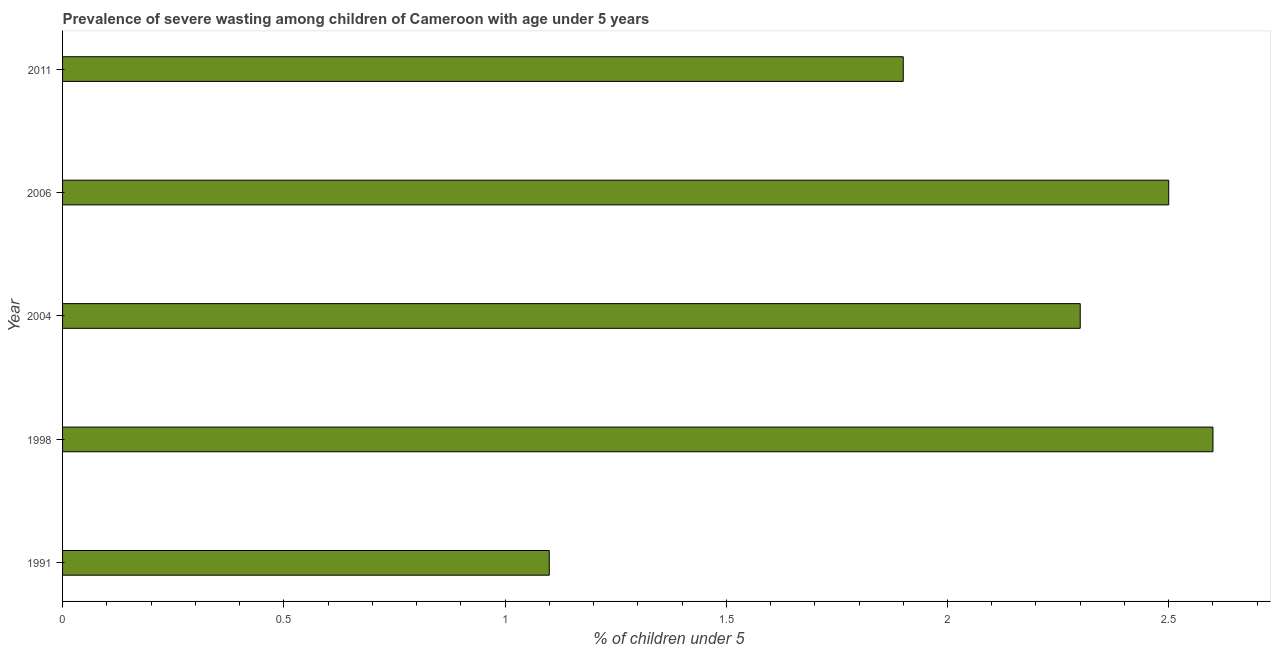Does the graph contain any zero values?
Provide a succinct answer. No. Does the graph contain grids?
Keep it short and to the point. No. What is the title of the graph?
Offer a terse response. Prevalence of severe wasting among children of Cameroon with age under 5 years. What is the label or title of the X-axis?
Offer a very short reply.  % of children under 5. What is the prevalence of severe wasting in 2011?
Give a very brief answer. 1.9. Across all years, what is the maximum prevalence of severe wasting?
Ensure brevity in your answer.  2.6. Across all years, what is the minimum prevalence of severe wasting?
Keep it short and to the point. 1.1. What is the sum of the prevalence of severe wasting?
Offer a very short reply. 10.4. What is the average prevalence of severe wasting per year?
Provide a succinct answer. 2.08. What is the median prevalence of severe wasting?
Offer a very short reply. 2.3. In how many years, is the prevalence of severe wasting greater than 0.6 %?
Your answer should be very brief. 5. What is the ratio of the prevalence of severe wasting in 1991 to that in 2004?
Provide a short and direct response. 0.48. Is the difference between the prevalence of severe wasting in 1998 and 2006 greater than the difference between any two years?
Ensure brevity in your answer.  No. Is the sum of the prevalence of severe wasting in 2006 and 2011 greater than the maximum prevalence of severe wasting across all years?
Keep it short and to the point. Yes. In how many years, is the prevalence of severe wasting greater than the average prevalence of severe wasting taken over all years?
Provide a succinct answer. 3. How many bars are there?
Make the answer very short. 5. Are all the bars in the graph horizontal?
Keep it short and to the point. Yes. Are the values on the major ticks of X-axis written in scientific E-notation?
Provide a short and direct response. No. What is the  % of children under 5 in 1991?
Make the answer very short. 1.1. What is the  % of children under 5 of 1998?
Your answer should be very brief. 2.6. What is the  % of children under 5 in 2004?
Ensure brevity in your answer.  2.3. What is the  % of children under 5 of 2006?
Your answer should be compact. 2.5. What is the  % of children under 5 in 2011?
Your answer should be compact. 1.9. What is the difference between the  % of children under 5 in 1991 and 2004?
Your response must be concise. -1.2. What is the difference between the  % of children under 5 in 1991 and 2011?
Give a very brief answer. -0.8. What is the difference between the  % of children under 5 in 2004 and 2011?
Your response must be concise. 0.4. What is the difference between the  % of children under 5 in 2006 and 2011?
Your answer should be compact. 0.6. What is the ratio of the  % of children under 5 in 1991 to that in 1998?
Provide a succinct answer. 0.42. What is the ratio of the  % of children under 5 in 1991 to that in 2004?
Your response must be concise. 0.48. What is the ratio of the  % of children under 5 in 1991 to that in 2006?
Provide a succinct answer. 0.44. What is the ratio of the  % of children under 5 in 1991 to that in 2011?
Offer a terse response. 0.58. What is the ratio of the  % of children under 5 in 1998 to that in 2004?
Offer a terse response. 1.13. What is the ratio of the  % of children under 5 in 1998 to that in 2011?
Your response must be concise. 1.37. What is the ratio of the  % of children under 5 in 2004 to that in 2011?
Offer a very short reply. 1.21. What is the ratio of the  % of children under 5 in 2006 to that in 2011?
Your answer should be very brief. 1.32. 